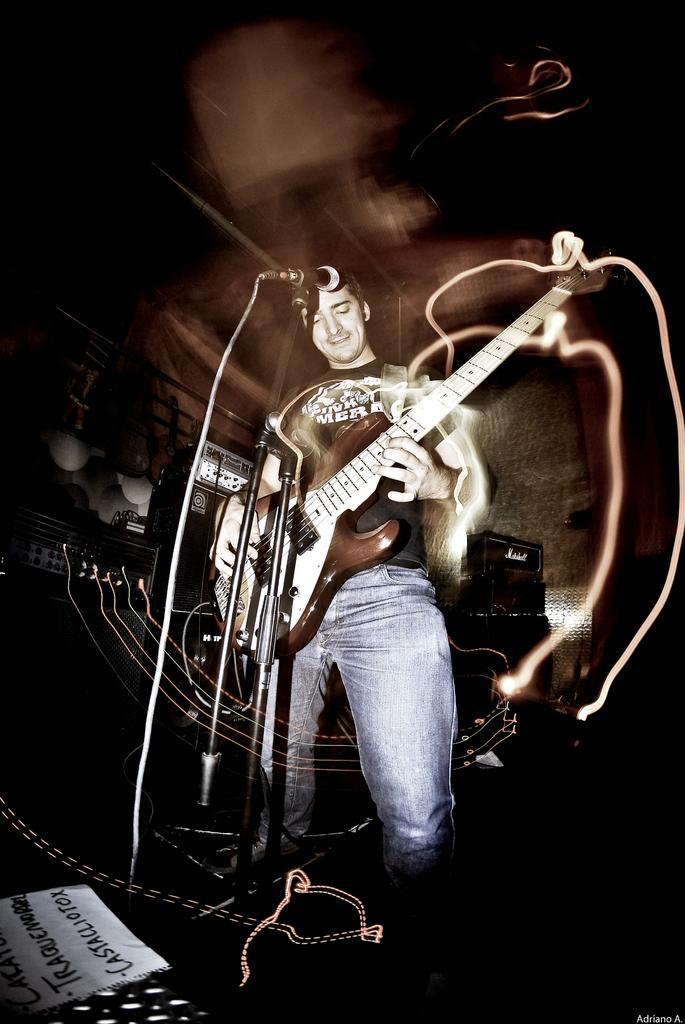Can you describe this image briefly? In the image there is a man standing and holding a guitar and playing it in front of a microphone, on left side we can also see a paper. 